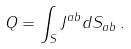<formula> <loc_0><loc_0><loc_500><loc_500>Q = \int _ { S } J ^ { a b } d S _ { a b } \, .</formula> 